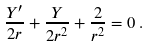<formula> <loc_0><loc_0><loc_500><loc_500>\frac { Y ^ { \prime } } { 2 r } + \frac { Y } { 2 r ^ { 2 } } + \frac { 2 } { r ^ { 2 } } = 0 \, .</formula> 